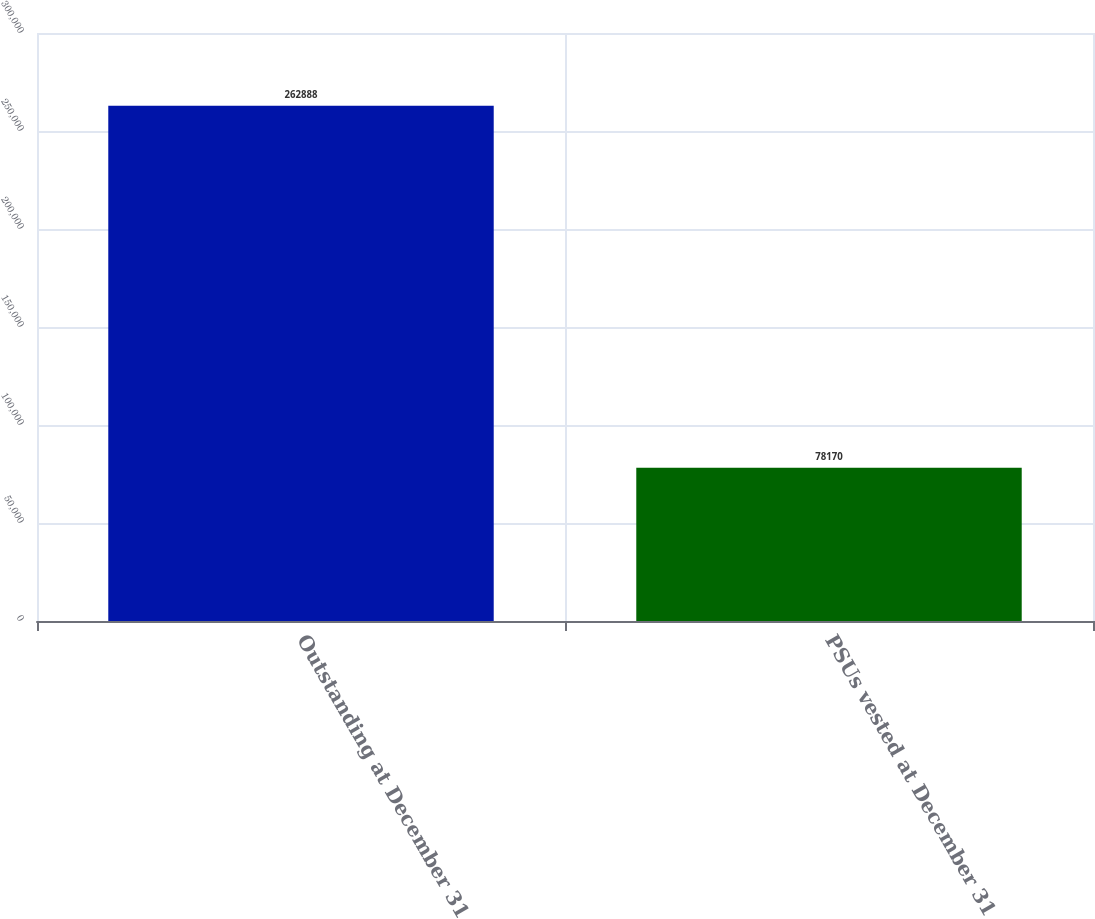Convert chart to OTSL. <chart><loc_0><loc_0><loc_500><loc_500><bar_chart><fcel>Outstanding at December 31<fcel>PSUs vested at December 31<nl><fcel>262888<fcel>78170<nl></chart> 